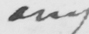What is written in this line of handwriting? any 